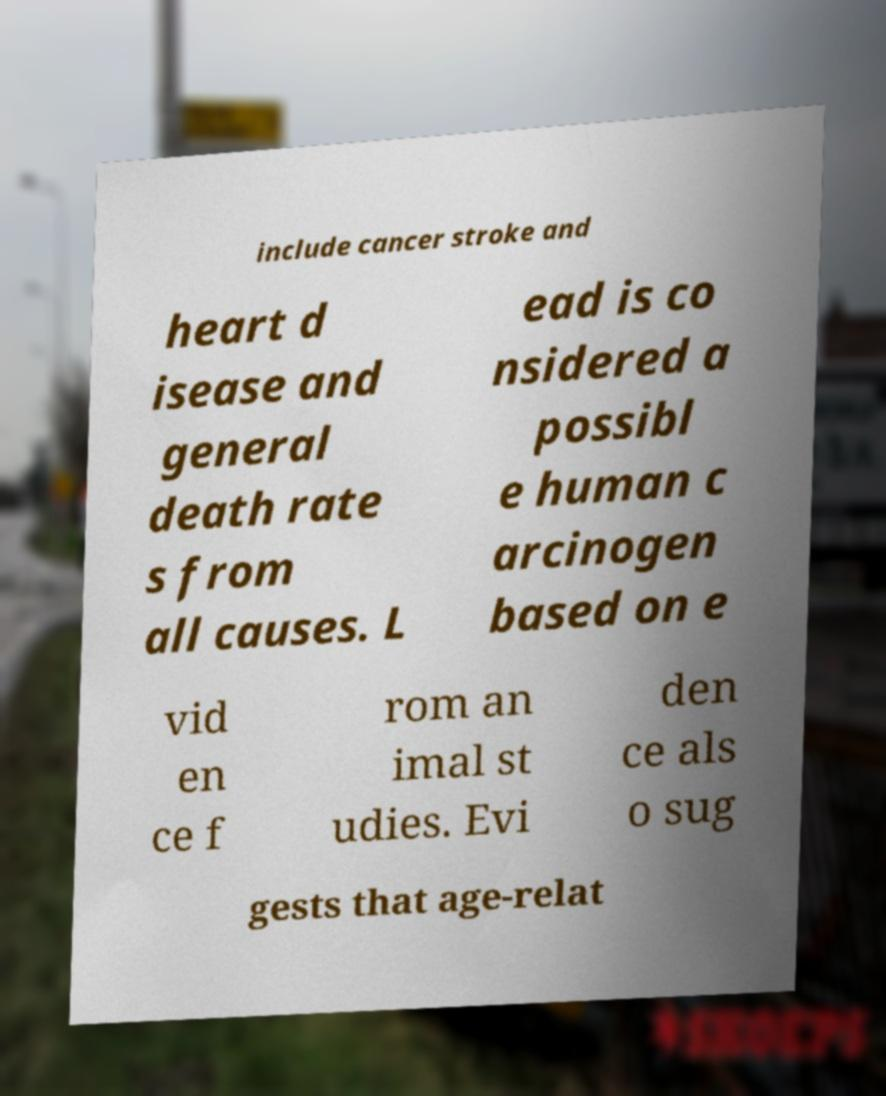I need the written content from this picture converted into text. Can you do that? include cancer stroke and heart d isease and general death rate s from all causes. L ead is co nsidered a possibl e human c arcinogen based on e vid en ce f rom an imal st udies. Evi den ce als o sug gests that age-relat 